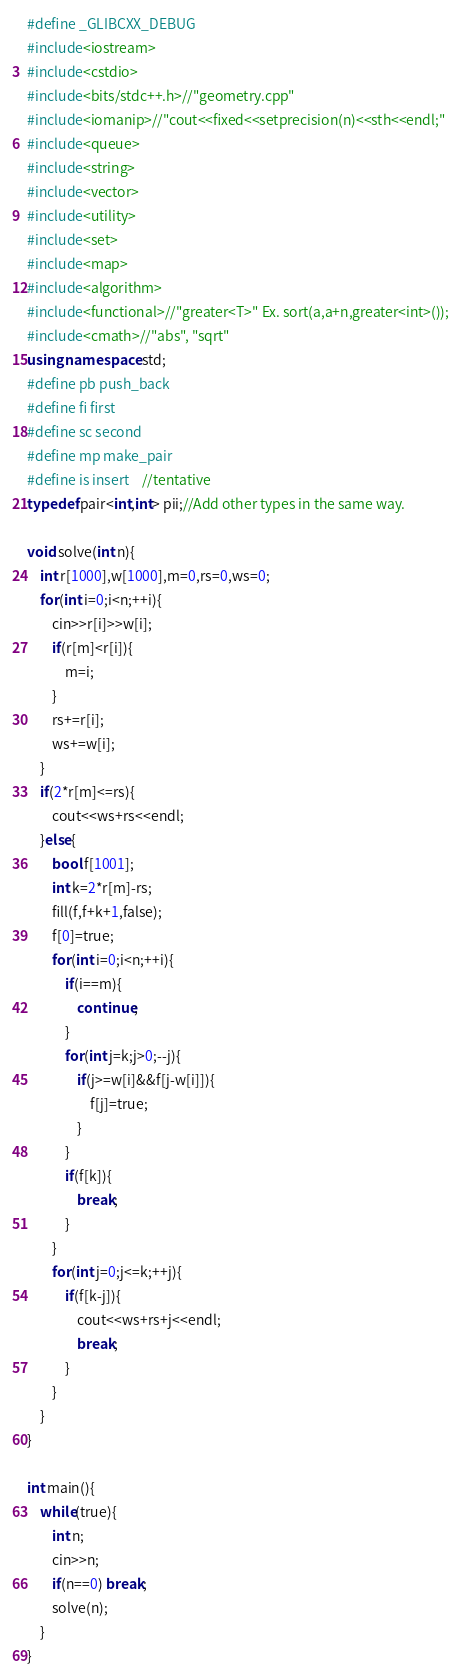Convert code to text. <code><loc_0><loc_0><loc_500><loc_500><_C++_>#define _GLIBCXX_DEBUG
#include<iostream>
#include<cstdio>
#include<bits/stdc++.h>//"geometry.cpp"
#include<iomanip>//"cout<<fixed<<setprecision(n)<<sth<<endl;"
#include<queue>
#include<string>
#include<vector>
#include<utility>
#include<set>
#include<map>
#include<algorithm>
#include<functional>//"greater<T>" Ex. sort(a,a+n,greater<int>());
#include<cmath>//"abs", "sqrt"
using namespace std;
#define pb push_back
#define fi first
#define sc second
#define mp make_pair
#define is insert	//tentative
typedef pair<int,int> pii;//Add other types in the same way.

void solve(int n){
	int r[1000],w[1000],m=0,rs=0,ws=0;
	for(int i=0;i<n;++i){
		cin>>r[i]>>w[i];
		if(r[m]<r[i]){
			m=i;
		}
		rs+=r[i];
		ws+=w[i];
	}
	if(2*r[m]<=rs){
		cout<<ws+rs<<endl;
	}else{
		bool f[1001];
		int k=2*r[m]-rs;
		fill(f,f+k+1,false);
		f[0]=true;
		for(int i=0;i<n;++i){
			if(i==m){
				continue;
			}
			for(int j=k;j>0;--j){
				if(j>=w[i]&&f[j-w[i]]){
					f[j]=true;
				}
			}
			if(f[k]){
				break;
			}
		}
		for(int j=0;j<=k;++j){
			if(f[k-j]){
				cout<<ws+rs+j<<endl;
				break;
			}
		}
	}
}

int main(){	
	while(true){
		int n;
		cin>>n;
		if(n==0) break;
		solve(n);
	}
}</code> 